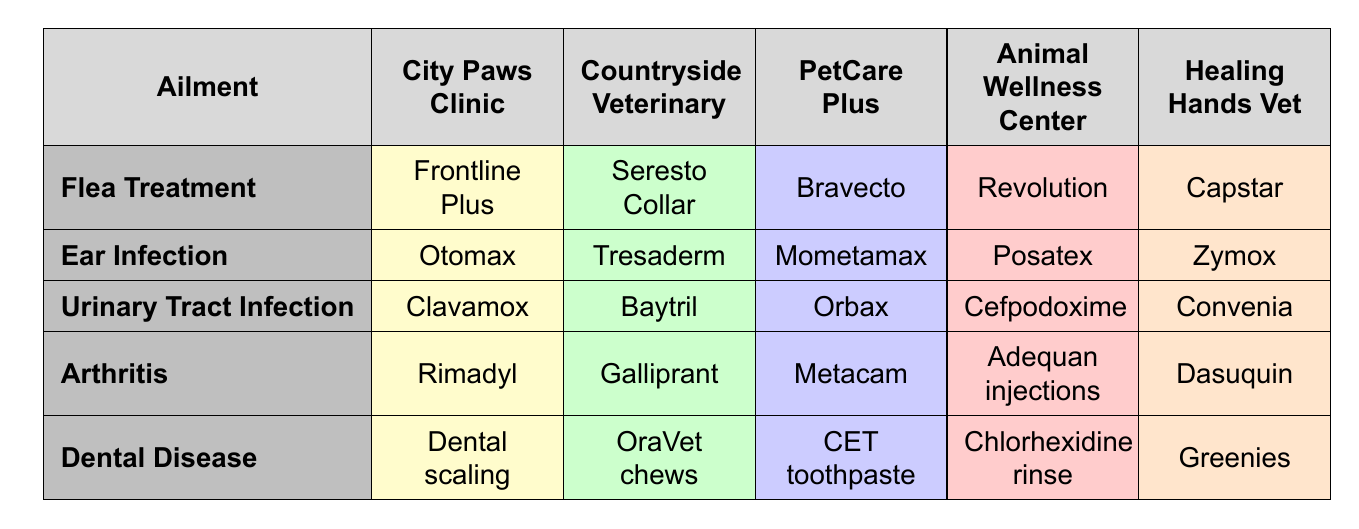What treatment does City Paws Clinic recommend for flea treatment? By looking at the 'Flea Treatment' row under the 'City Paws Clinic' column, we see that the recommended treatment is 'Frontline Plus'.
Answer: Frontline Plus Which clinic offers Mometamax for ear infections? In the 'Ear Infection' row, we check the 'PetCare Plus' column and find that it offers 'Mometamax'.
Answer: PetCare Plus Is Galliprant used for treating arthritis? The 'Arthritis' row indicates that Galliprant is listed under the 'Countryside Veterinary' column, confirming its use for arthritis treatment.
Answer: Yes What is the most commonly mentioned treatment for urinary tract infections across the clinics? Checking the 'Urinary Tract Infection' row, we see that different treatments are listed for each clinic, so they are all equally mentioned (not shared). Therefore, no single treatment stands out as the most mentioned.
Answer: No common treatment Which clinic has the most diverse set of options for dental disease? In the 'Dental Disease' row, we find different treatments listed across all clinics without any repeated treatments, indicating each clinic has a unique approach. Thus, there's no definitive answer regarding diversity as they all have unique options.
Answer: All clinics provide unique options What is the difference in treatment recommendations for arthritis between City Paws Clinic and Healing Hands Vet? City Paws Clinic recommends 'Rimadyl' while Healing Hands Vet suggests 'Dasuquin'. This shows a variety of approaches in treating arthritis between the two clinics. The difference lies in the specific medications provided.
Answer: Rimadyl vs. Dasuquin Which clinic uses Capstar for flea treatment? In the 'Flea Treatment' row, the last column under 'Healing Hands Vet' shows that 'Capstar' is the treatment recommended for flea treatment at this clinic.
Answer: Healing Hands Vet How many clinics offer dental scaling as a treatment for dental disease? 'Dental scaling' is listed only under the 'City Paws Clinic' column in the 'Dental Disease' row, meaning only one clinic offers this treatment.
Answer: One clinic If you combine the treatments for ear infections offered by City Paws Clinic and Countryside Veterinary, how many distinct treatments do you get? 'City Paws Clinic' offers 'Otomax' and 'Countryside Veterinary' offers 'Tresaderm'. Since these are two different treatments, the total count of distinct treatments from both clinics is 2.
Answer: 2 distinct treatments What treatment is exclusively offered by Animal Wellness Center for arthritis? Looking under the 'Arthritis' row in the 'Animal Wellness Center' column, we find that they offer 'Adequan injections', which is exclusive to that clinic for this ailment.
Answer: Adequan injections Which treatment for Urinary Tract Infection does PetCare Plus use? In the 'Urinary Tract Infection' row under the 'PetCare Plus' column, the treatment listed is 'Orbax'.
Answer: Orbax 